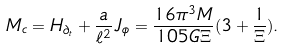<formula> <loc_0><loc_0><loc_500><loc_500>M _ { c } = H _ { \partial _ { t } } + \frac { a } { \ell ^ { 2 } } J _ { \phi } = \frac { 1 6 \pi ^ { 3 } M } { 1 0 5 G \Xi } ( 3 + \frac { 1 } { \Xi } ) .</formula> 